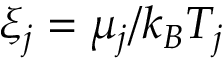Convert formula to latex. <formula><loc_0><loc_0><loc_500><loc_500>\xi _ { j } = \mu _ { j } / k _ { B } T _ { j }</formula> 